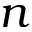<formula> <loc_0><loc_0><loc_500><loc_500>n</formula> 